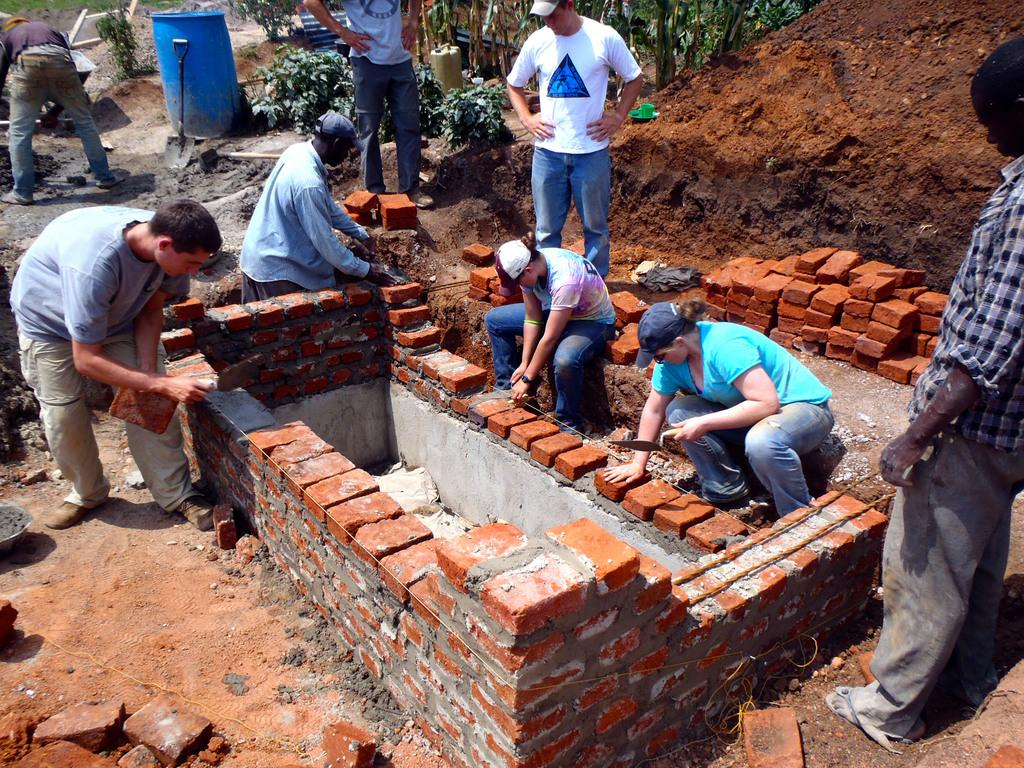Who is present in the image? There are people in the image. What are the people doing in the image? The people are constructing with bricks. What other objects can be seen in the image? There are plants, bricks, and sand in the image. What type of whip can be seen in the image? There is no whip present in the image. What toys are the people playing with in the image? There are no toys present in the image; the people are constructing with bricks. 